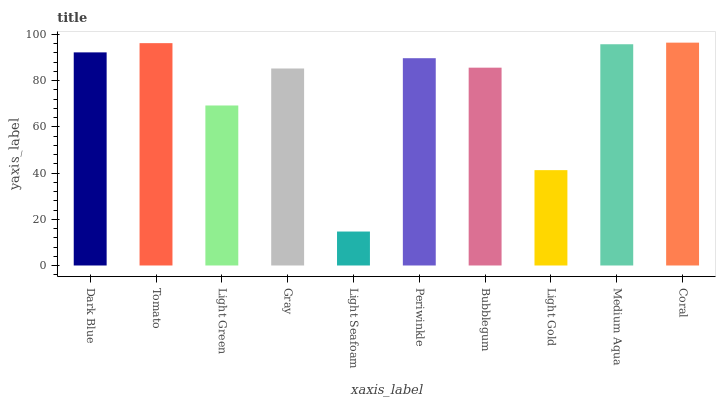Is Light Seafoam the minimum?
Answer yes or no. Yes. Is Coral the maximum?
Answer yes or no. Yes. Is Tomato the minimum?
Answer yes or no. No. Is Tomato the maximum?
Answer yes or no. No. Is Tomato greater than Dark Blue?
Answer yes or no. Yes. Is Dark Blue less than Tomato?
Answer yes or no. Yes. Is Dark Blue greater than Tomato?
Answer yes or no. No. Is Tomato less than Dark Blue?
Answer yes or no. No. Is Periwinkle the high median?
Answer yes or no. Yes. Is Bubblegum the low median?
Answer yes or no. Yes. Is Gray the high median?
Answer yes or no. No. Is Medium Aqua the low median?
Answer yes or no. No. 